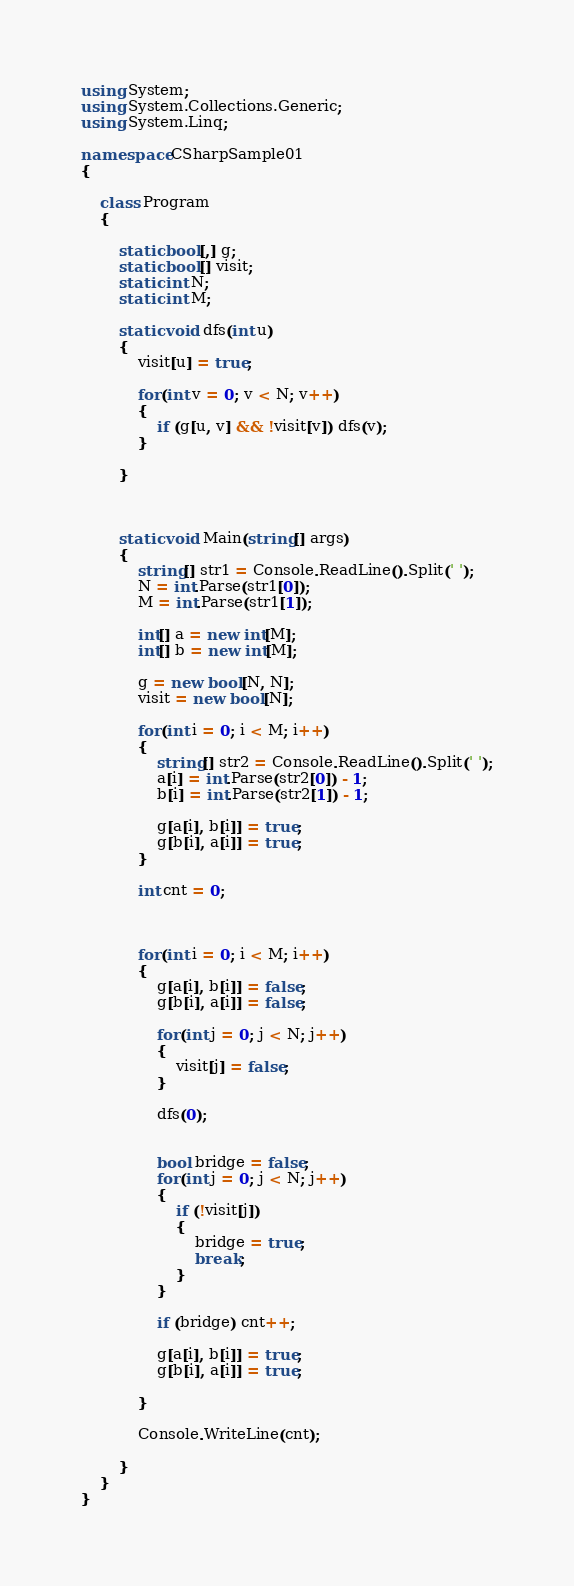Convert code to text. <code><loc_0><loc_0><loc_500><loc_500><_C#_>using System;
using System.Collections.Generic;
using System.Linq;

namespace CSharpSample01
{

    class Program
    {

        static bool[,] g;
        static bool[] visit;
        static int N;
        static int M;
        
        static void dfs(int u)
        {
            visit[u] = true;

            for(int v = 0; v < N; v++)
            {
                if (g[u, v] && !visit[v]) dfs(v);
            }
            
        }


        
        static void Main(string[] args)
        {
            string[] str1 = Console.ReadLine().Split(' ');
            N = int.Parse(str1[0]);
            M = int.Parse(str1[1]);

            int[] a = new int[M];
            int[] b = new int[M];

            g = new bool[N, N];
            visit = new bool[N];
            
            for(int i = 0; i < M; i++)
            {
                string[] str2 = Console.ReadLine().Split(' ');
                a[i] = int.Parse(str2[0]) - 1;
                b[i] = int.Parse(str2[1]) - 1;

                g[a[i], b[i]] = true;
                g[b[i], a[i]] = true;
            }

            int cnt = 0;

            

            for(int i = 0; i < M; i++)
            {
                g[a[i], b[i]] = false;
                g[b[i], a[i]] = false;

                for(int j = 0; j < N; j++)
                {
                    visit[j] = false;
                }

                dfs(0);

                
                bool bridge = false;
                for(int j = 0; j < N; j++)
                {
                    if (!visit[j])
                    {
                        bridge = true;
                        break;
                    }                  
                }

                if (bridge) cnt++;

                g[a[i], b[i]] = true;
                g[b[i], a[i]] = true;

            }
            
            Console.WriteLine(cnt);

        }
    }
}
</code> 